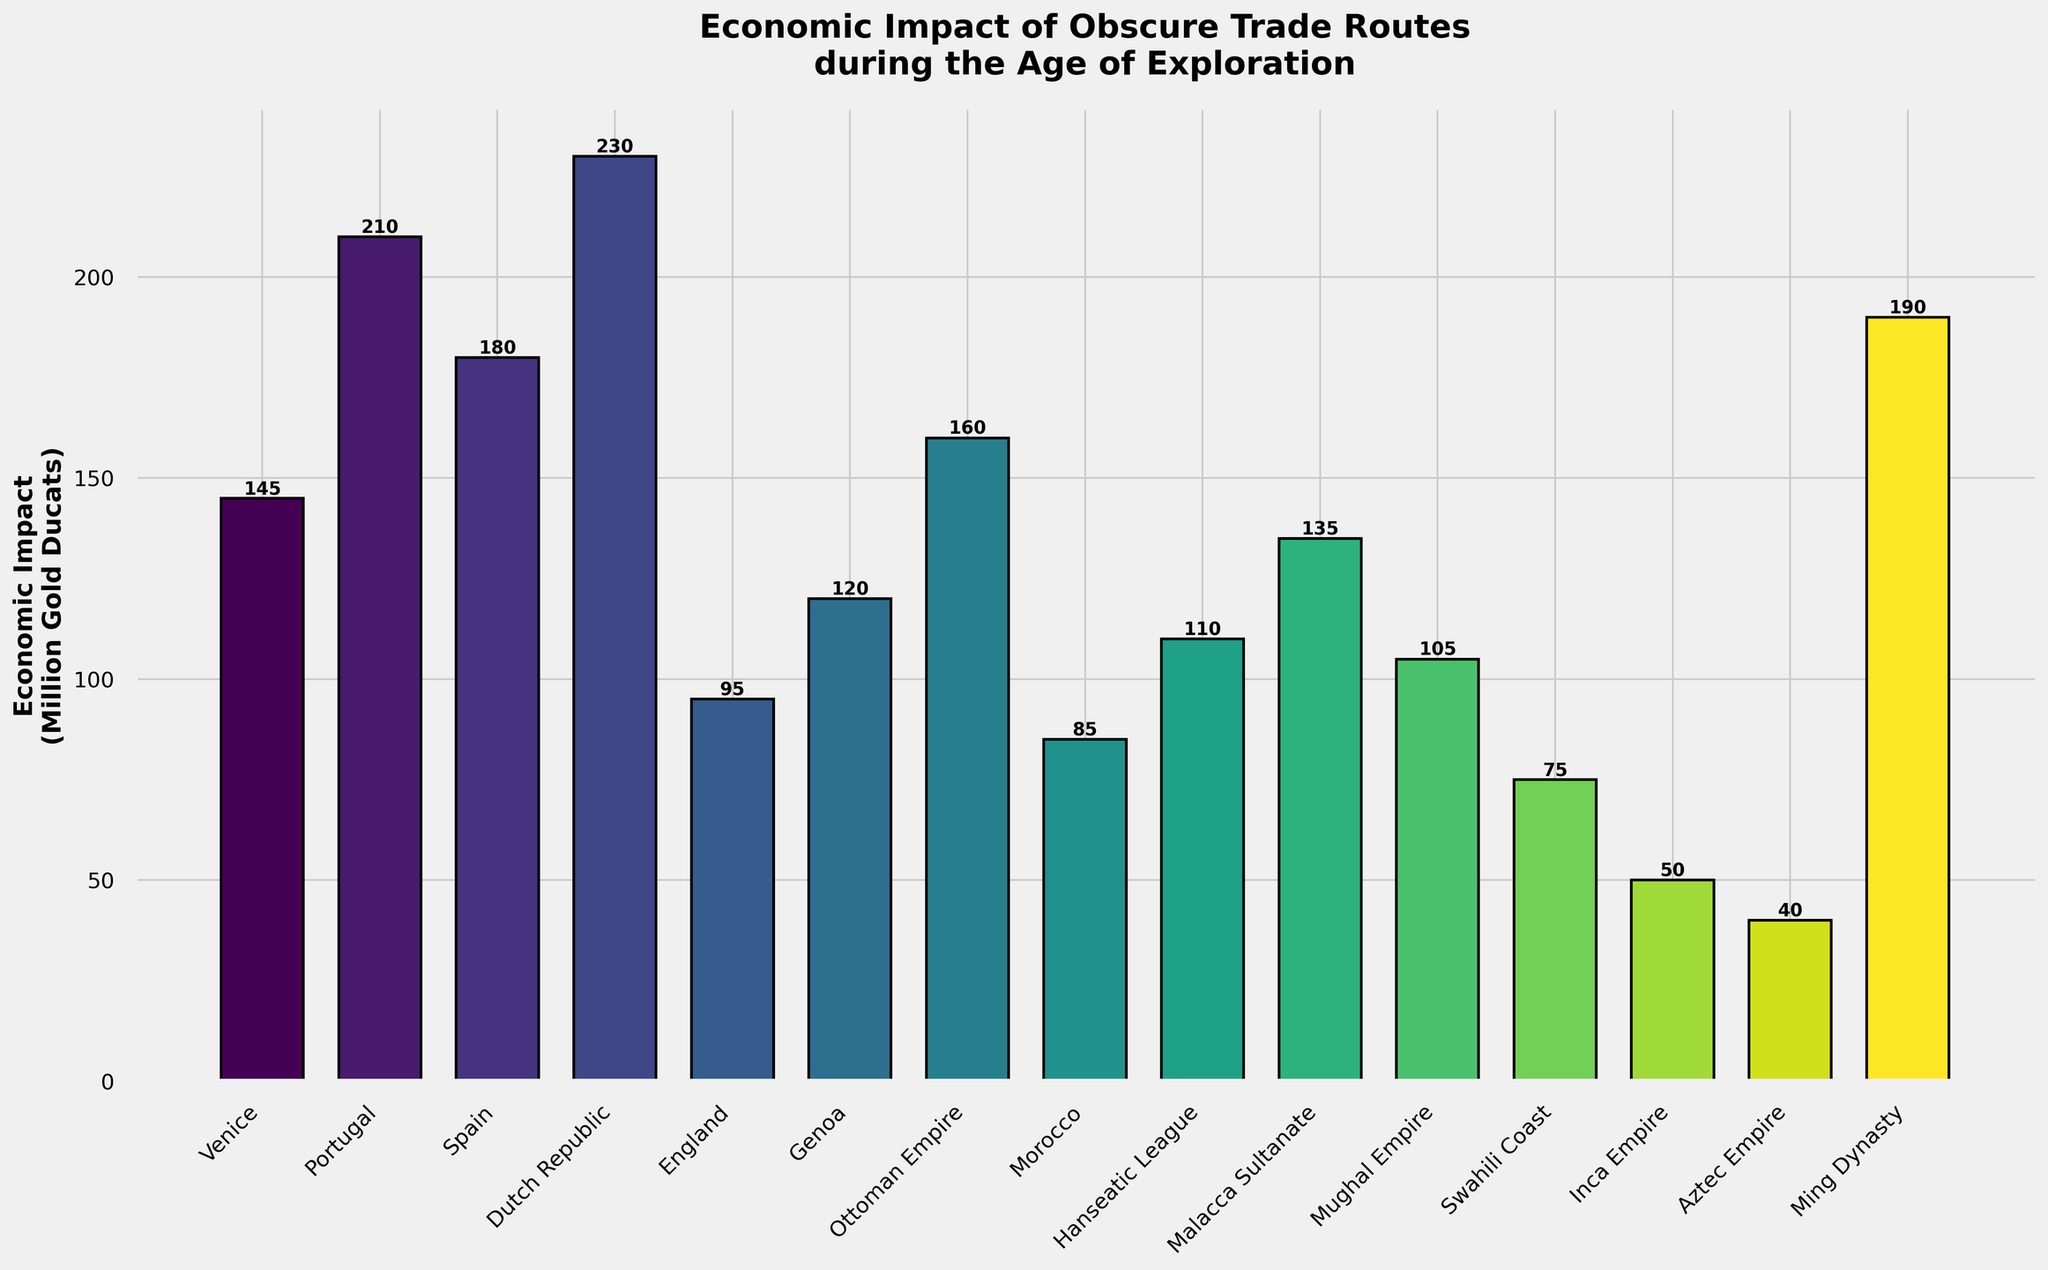What is the region with the highest economic impact? Look for the tallest bar in the chart, which represents the region with the highest economic impact. In this plot, the Dutch Republic has the tallest bar.
Answer: Dutch Republic Which two regions have the closest economic impact values? Compare the heights of the bars visually to find the two that are closest in height. The Venice and Malacca Sultanate bars appear closest in height.
Answer: Venice and Malacca Sultanate What is the total economic impact of the Red Sea Spice Route and the Cape of Good Hope Route? Find the bars labeled "Ottoman Empire" and "Portugal" and add their heights. The Red Sea Spice Route has an impact of 160, and the Cape of Good Hope Route has an impact of 210. The sum is 160 + 210 = 370.
Answer: 370 Which region has a greater economic impact: the Swahili Coast or the Aztec Empire? Compare the heights of the bars for "Swahili Coast" and "Aztec Empire". The Swahili Coast bar is taller than the Aztec Empire bar.
Answer: Swahili Coast What is the average economic impact of all the regions shown in the chart? Sum the economic impacts of all regions and divide by the number of regions (15). The sum is 145 + 210 + 180 + 230 + 95 + 120 + 160 + 85 + 110 + 135 + 105 + 75 + 50 + 40 + 190 = 1930. The average is 1930 / 15 = 128.67.
Answer: 128.67 Which region's trade route has a lesser economic impact than England's Muscovy Company Arctic Route? Find the bar for "England" and compare its height of 95 with other bars. The regions with lesser impact are Morocco, Swahili Coast, Inca Empire, and Aztec Empire.
Answer: Morocco, Swahili Coast, Inca Empire, and Aztec Empire What is the difference in economic impact between the VOC Pepper Trade and the Chincha Islands Guano Trade? Find the bars for "Dutch Republic" and "Inca Empire" and subtract the smaller height from the larger. The VOC Pepper Trade impact is 230, and the Chincha Islands Guano Trade impact is 50. The difference is 230 - 50 = 180.
Answer: 180 How many regions have an economic impact greater than 150 million gold ducats? Count the number of bars with heights greater than 150. These regions are Dutch Republic, Portugal, Spain, Ottoman Empire, and Ming Dynasty. There are 5 such regions.
Answer: 5 Which region has the shortest bar, and what is its economic impact? Identify the shortest bar on the chart. The shortest bar belongs to the Aztec Empire with an economic impact of 40 million gold ducats.
Answer: Aztec Empire, 40 What is the combined economic impact of the trade routes for the Dutch Republic, Spain, and the Ming Dynasty? Add the heights of the bars for "Dutch Republic," "Spain," and "Ming Dynasty." The impacts are 230, 180, and 190 respectively. The total is 230 + 180 + 190 = 600.
Answer: 600 